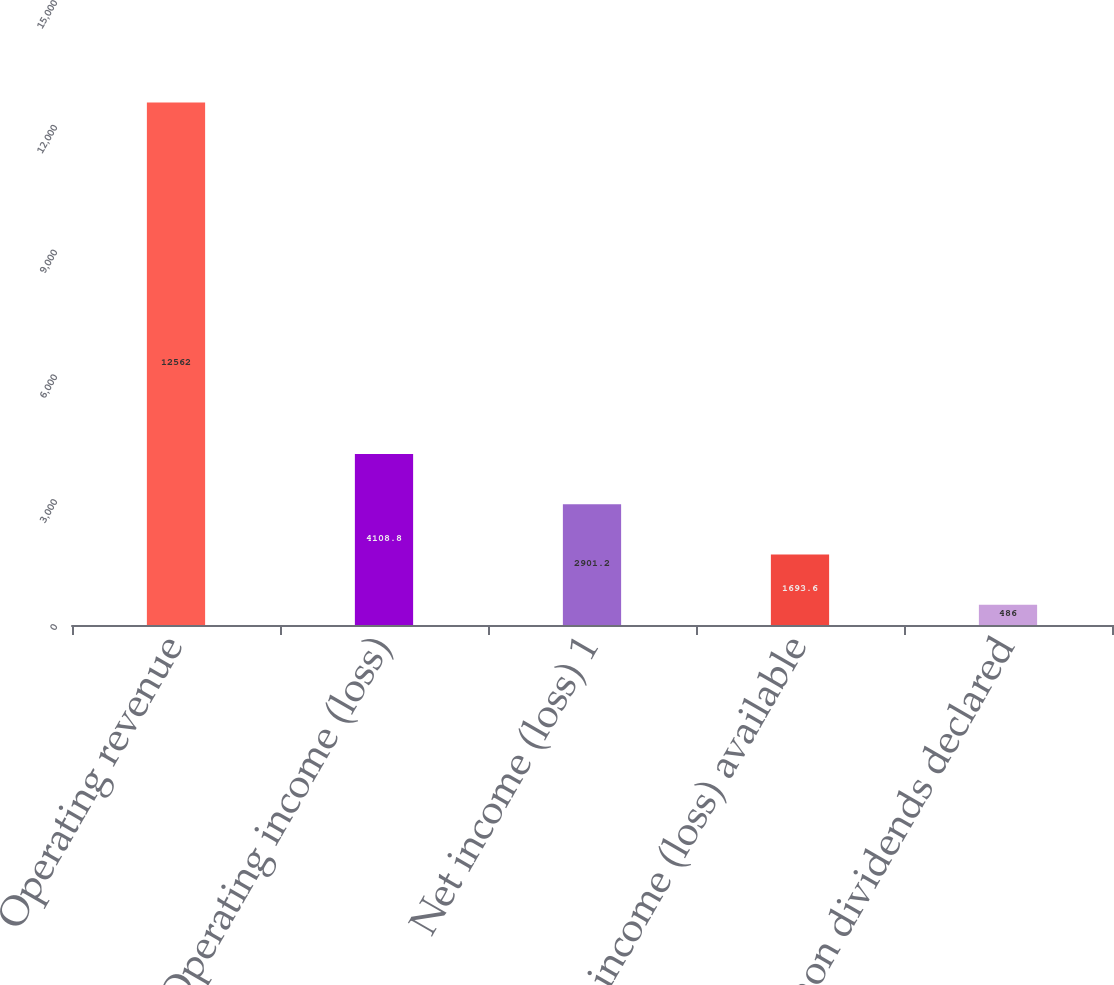Convert chart to OTSL. <chart><loc_0><loc_0><loc_500><loc_500><bar_chart><fcel>Operating revenue<fcel>Operating income (loss)<fcel>Net income (loss) 1<fcel>Net income (loss) available<fcel>Common dividends declared<nl><fcel>12562<fcel>4108.8<fcel>2901.2<fcel>1693.6<fcel>486<nl></chart> 